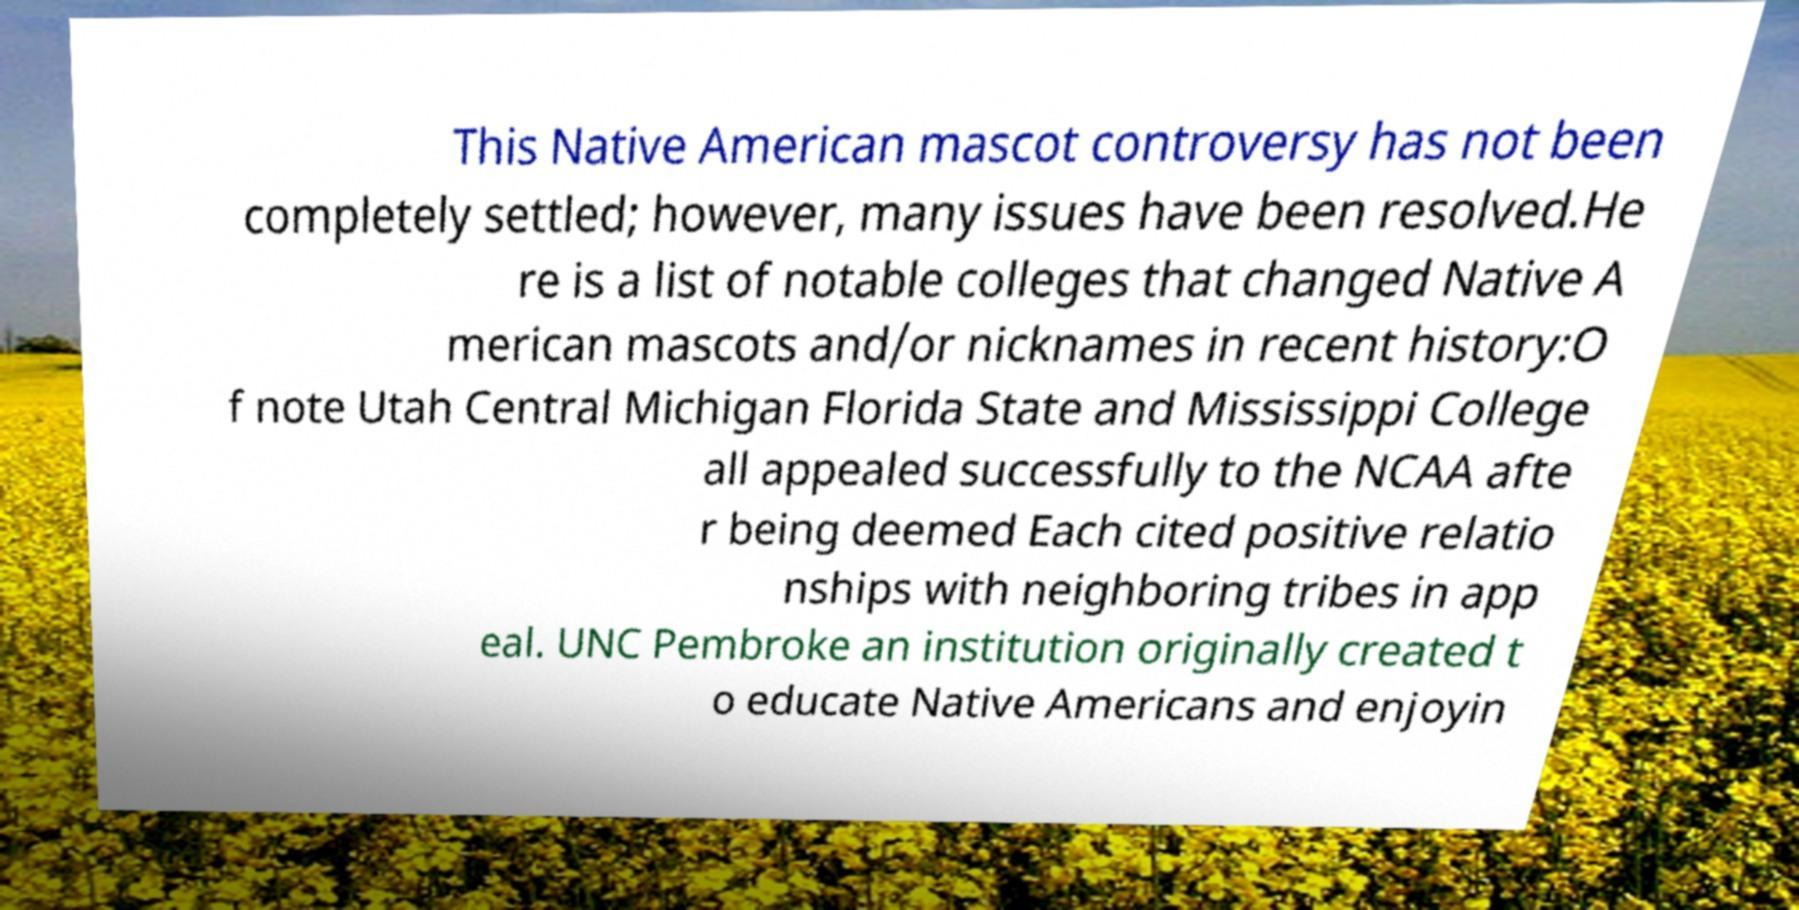Please read and relay the text visible in this image. What does it say? This Native American mascot controversy has not been completely settled; however, many issues have been resolved.He re is a list of notable colleges that changed Native A merican mascots and/or nicknames in recent history:O f note Utah Central Michigan Florida State and Mississippi College all appealed successfully to the NCAA afte r being deemed Each cited positive relatio nships with neighboring tribes in app eal. UNC Pembroke an institution originally created t o educate Native Americans and enjoyin 